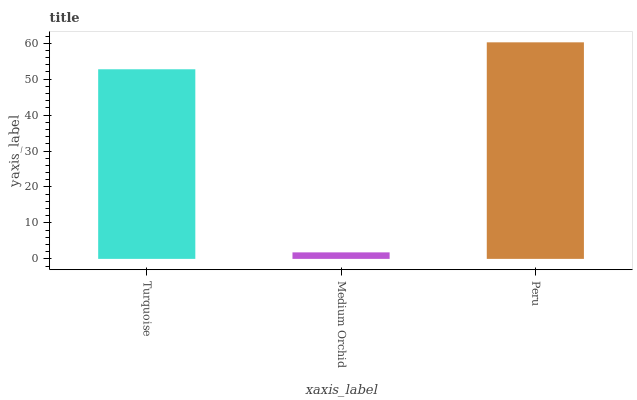Is Medium Orchid the minimum?
Answer yes or no. Yes. Is Peru the maximum?
Answer yes or no. Yes. Is Peru the minimum?
Answer yes or no. No. Is Medium Orchid the maximum?
Answer yes or no. No. Is Peru greater than Medium Orchid?
Answer yes or no. Yes. Is Medium Orchid less than Peru?
Answer yes or no. Yes. Is Medium Orchid greater than Peru?
Answer yes or no. No. Is Peru less than Medium Orchid?
Answer yes or no. No. Is Turquoise the high median?
Answer yes or no. Yes. Is Turquoise the low median?
Answer yes or no. Yes. Is Peru the high median?
Answer yes or no. No. Is Medium Orchid the low median?
Answer yes or no. No. 